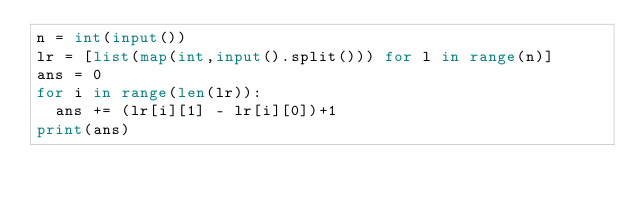Convert code to text. <code><loc_0><loc_0><loc_500><loc_500><_Python_>n = int(input())
lr = [list(map(int,input().split())) for l in range(n)]
ans = 0
for i in range(len(lr)):
  ans += (lr[i][1] - lr[i][0])+1
print(ans)</code> 